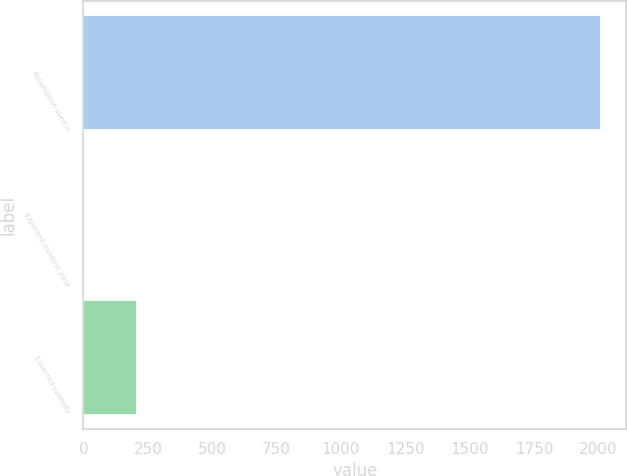Convert chart. <chart><loc_0><loc_0><loc_500><loc_500><bar_chart><fcel>Assumption used in<fcel>Expected dividend yield<fcel>Expected volatility<nl><fcel>2007<fcel>1.72<fcel>202.25<nl></chart> 